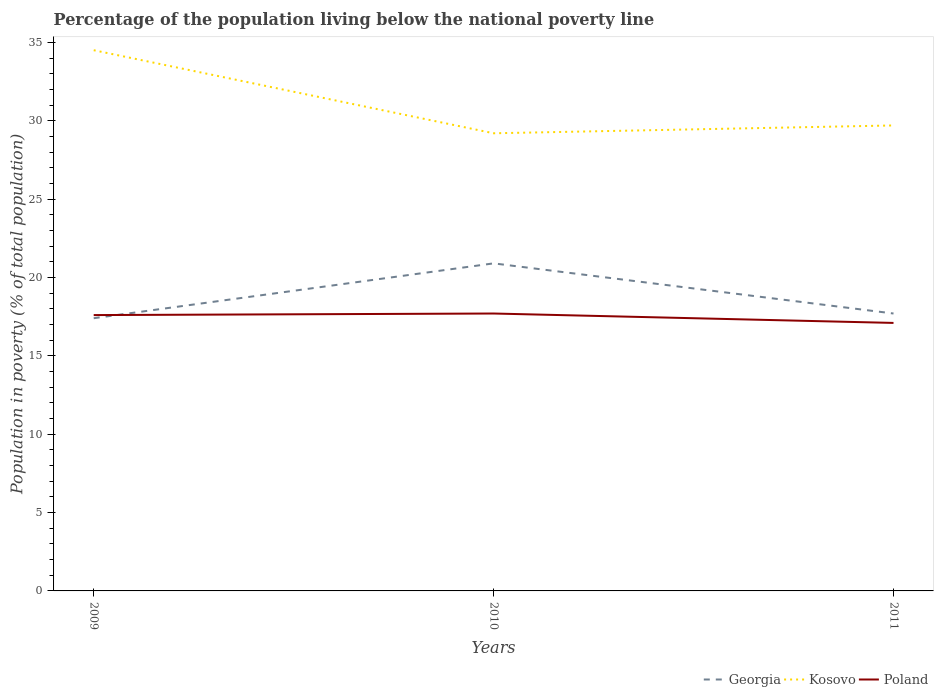How many different coloured lines are there?
Give a very brief answer. 3. Across all years, what is the maximum percentage of the population living below the national poverty line in Poland?
Ensure brevity in your answer.  17.1. In which year was the percentage of the population living below the national poverty line in Georgia maximum?
Offer a terse response. 2009. What is the total percentage of the population living below the national poverty line in Poland in the graph?
Give a very brief answer. 0.6. What is the difference between the highest and the second highest percentage of the population living below the national poverty line in Poland?
Your answer should be very brief. 0.6. What is the difference between the highest and the lowest percentage of the population living below the national poverty line in Georgia?
Ensure brevity in your answer.  1. How many lines are there?
Offer a terse response. 3. How many years are there in the graph?
Give a very brief answer. 3. Does the graph contain grids?
Your answer should be compact. No. How many legend labels are there?
Your response must be concise. 3. What is the title of the graph?
Provide a succinct answer. Percentage of the population living below the national poverty line. Does "Singapore" appear as one of the legend labels in the graph?
Your answer should be compact. No. What is the label or title of the Y-axis?
Your response must be concise. Population in poverty (% of total population). What is the Population in poverty (% of total population) in Georgia in 2009?
Offer a very short reply. 17.4. What is the Population in poverty (% of total population) of Kosovo in 2009?
Make the answer very short. 34.5. What is the Population in poverty (% of total population) in Poland in 2009?
Provide a succinct answer. 17.6. What is the Population in poverty (% of total population) in Georgia in 2010?
Offer a very short reply. 20.9. What is the Population in poverty (% of total population) in Kosovo in 2010?
Provide a short and direct response. 29.2. What is the Population in poverty (% of total population) in Poland in 2010?
Make the answer very short. 17.7. What is the Population in poverty (% of total population) in Kosovo in 2011?
Your answer should be compact. 29.7. What is the Population in poverty (% of total population) in Poland in 2011?
Give a very brief answer. 17.1. Across all years, what is the maximum Population in poverty (% of total population) in Georgia?
Ensure brevity in your answer.  20.9. Across all years, what is the maximum Population in poverty (% of total population) in Kosovo?
Your response must be concise. 34.5. Across all years, what is the maximum Population in poverty (% of total population) of Poland?
Ensure brevity in your answer.  17.7. Across all years, what is the minimum Population in poverty (% of total population) in Kosovo?
Keep it short and to the point. 29.2. Across all years, what is the minimum Population in poverty (% of total population) of Poland?
Your answer should be compact. 17.1. What is the total Population in poverty (% of total population) in Kosovo in the graph?
Make the answer very short. 93.4. What is the total Population in poverty (% of total population) in Poland in the graph?
Your answer should be very brief. 52.4. What is the difference between the Population in poverty (% of total population) in Kosovo in 2009 and that in 2010?
Your answer should be compact. 5.3. What is the difference between the Population in poverty (% of total population) in Poland in 2009 and that in 2010?
Offer a very short reply. -0.1. What is the difference between the Population in poverty (% of total population) of Georgia in 2009 and that in 2011?
Provide a short and direct response. -0.3. What is the difference between the Population in poverty (% of total population) of Kosovo in 2009 and that in 2011?
Keep it short and to the point. 4.8. What is the difference between the Population in poverty (% of total population) in Kosovo in 2010 and that in 2011?
Offer a terse response. -0.5. What is the difference between the Population in poverty (% of total population) of Poland in 2010 and that in 2011?
Your answer should be compact. 0.6. What is the difference between the Population in poverty (% of total population) in Kosovo in 2009 and the Population in poverty (% of total population) in Poland in 2010?
Offer a terse response. 16.8. What is the difference between the Population in poverty (% of total population) of Georgia in 2010 and the Population in poverty (% of total population) of Kosovo in 2011?
Offer a terse response. -8.8. What is the difference between the Population in poverty (% of total population) of Georgia in 2010 and the Population in poverty (% of total population) of Poland in 2011?
Ensure brevity in your answer.  3.8. What is the difference between the Population in poverty (% of total population) of Kosovo in 2010 and the Population in poverty (% of total population) of Poland in 2011?
Your response must be concise. 12.1. What is the average Population in poverty (% of total population) of Georgia per year?
Make the answer very short. 18.67. What is the average Population in poverty (% of total population) of Kosovo per year?
Provide a short and direct response. 31.13. What is the average Population in poverty (% of total population) in Poland per year?
Give a very brief answer. 17.47. In the year 2009, what is the difference between the Population in poverty (% of total population) of Georgia and Population in poverty (% of total population) of Kosovo?
Offer a terse response. -17.1. In the year 2009, what is the difference between the Population in poverty (% of total population) in Georgia and Population in poverty (% of total population) in Poland?
Your answer should be compact. -0.2. In the year 2010, what is the difference between the Population in poverty (% of total population) of Georgia and Population in poverty (% of total population) of Poland?
Your response must be concise. 3.2. In the year 2011, what is the difference between the Population in poverty (% of total population) in Georgia and Population in poverty (% of total population) in Poland?
Make the answer very short. 0.6. In the year 2011, what is the difference between the Population in poverty (% of total population) in Kosovo and Population in poverty (% of total population) in Poland?
Keep it short and to the point. 12.6. What is the ratio of the Population in poverty (% of total population) in Georgia in 2009 to that in 2010?
Your response must be concise. 0.83. What is the ratio of the Population in poverty (% of total population) in Kosovo in 2009 to that in 2010?
Your response must be concise. 1.18. What is the ratio of the Population in poverty (% of total population) of Georgia in 2009 to that in 2011?
Ensure brevity in your answer.  0.98. What is the ratio of the Population in poverty (% of total population) in Kosovo in 2009 to that in 2011?
Your answer should be compact. 1.16. What is the ratio of the Population in poverty (% of total population) of Poland in 2009 to that in 2011?
Make the answer very short. 1.03. What is the ratio of the Population in poverty (% of total population) in Georgia in 2010 to that in 2011?
Keep it short and to the point. 1.18. What is the ratio of the Population in poverty (% of total population) of Kosovo in 2010 to that in 2011?
Give a very brief answer. 0.98. What is the ratio of the Population in poverty (% of total population) of Poland in 2010 to that in 2011?
Offer a terse response. 1.04. What is the difference between the highest and the second highest Population in poverty (% of total population) in Kosovo?
Ensure brevity in your answer.  4.8. What is the difference between the highest and the second highest Population in poverty (% of total population) in Poland?
Give a very brief answer. 0.1. What is the difference between the highest and the lowest Population in poverty (% of total population) of Georgia?
Make the answer very short. 3.5. What is the difference between the highest and the lowest Population in poverty (% of total population) of Poland?
Give a very brief answer. 0.6. 